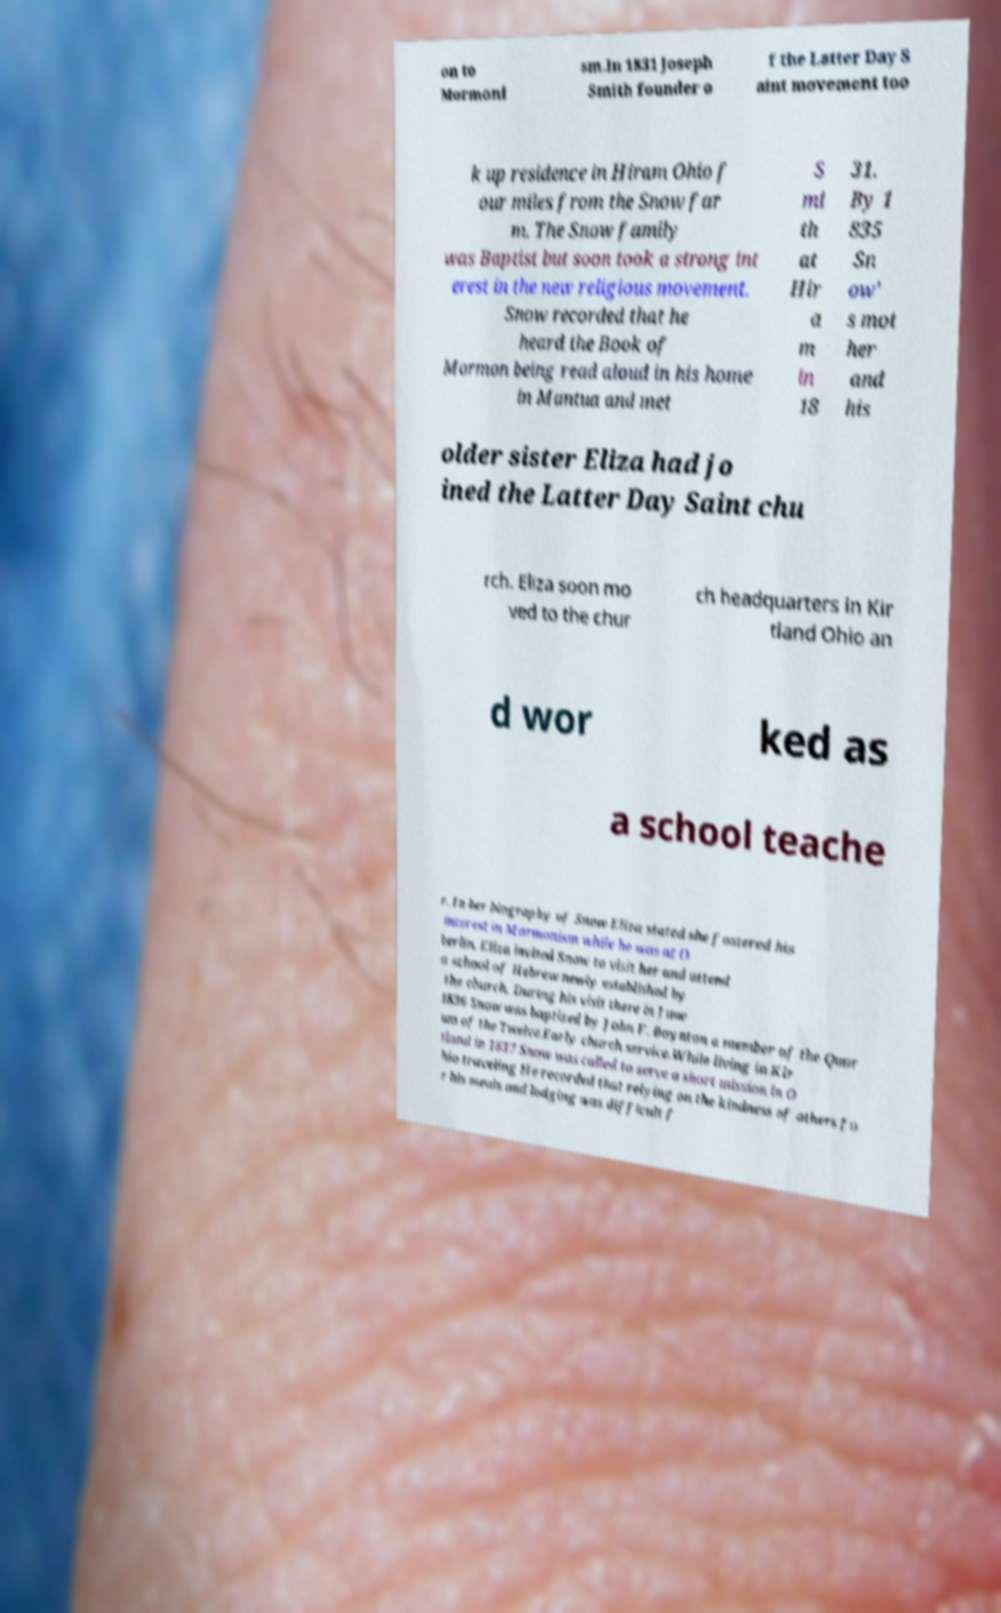Can you read and provide the text displayed in the image?This photo seems to have some interesting text. Can you extract and type it out for me? on to Mormoni sm.In 1831 Joseph Smith founder o f the Latter Day S aint movement too k up residence in Hiram Ohio f our miles from the Snow far m. The Snow family was Baptist but soon took a strong int erest in the new religious movement. Snow recorded that he heard the Book of Mormon being read aloud in his home in Mantua and met S mi th at Hir a m in 18 31. By 1 835 Sn ow' s mot her and his older sister Eliza had jo ined the Latter Day Saint chu rch. Eliza soon mo ved to the chur ch headquarters in Kir tland Ohio an d wor ked as a school teache r. In her biography of Snow Eliza stated she fostered his interest in Mormonism while he was at O berlin. Eliza invited Snow to visit her and attend a school of Hebrew newly established by the church. During his visit there in June 1836 Snow was baptized by John F. Boynton a member of the Quor um of the Twelve.Early church service.While living in Kir tland in 1837 Snow was called to serve a short mission in O hio traveling He recorded that relying on the kindness of others fo r his meals and lodging was difficult f 